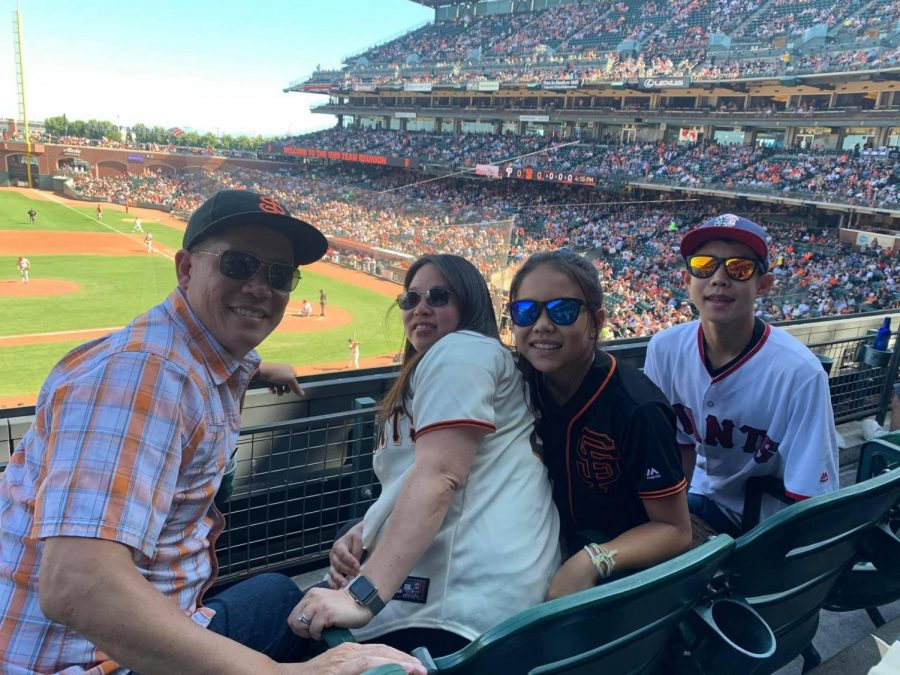What kind of activities might families enjoy besides watching the game in this stadium? Families can enjoy a variety of activities besides watching the game. Many stadiums have interactive zones for children, such as batting cages, pitching stations, or playgrounds themed around the sport. There would also be food vendors offering classic stadium snacks like hot dogs, nachos, and ice cream. Some areas might have photo booths with props to capture fun moments. Additionally, there can be team mascots roaming around, engaging with the fans and providing entertainment. Souvenir shops offer a range of merchandise, from team jerseys to memorable keepsakes. All these attractions ensure a fun-filled day for families, regardless of the game’s outcome. Can you envision a special event or theme day that the stadium might host to engage different audiences? Absolutely, the stadium might host a 'Retro Game Day' where everything from uniforms to the scoreboard adopts a classic, vintage look from a specific era, like the roaring '20s or the groovy '60s. Fans could be encouraged to dress in period-appropriate attire, creating a lively atmosphere of nostalgia. The event could feature entertainment like jazz bands or rock'n'roll performances in line with the chosen era. Specialized vendors offer themed food and drinks, and there could be historical exhibits showcasing the evolution of the sport. Activities such as parades and contests for best-dressed fans immerse everyone in the retro experience, making it a unique and memorable game day for all attendees. 